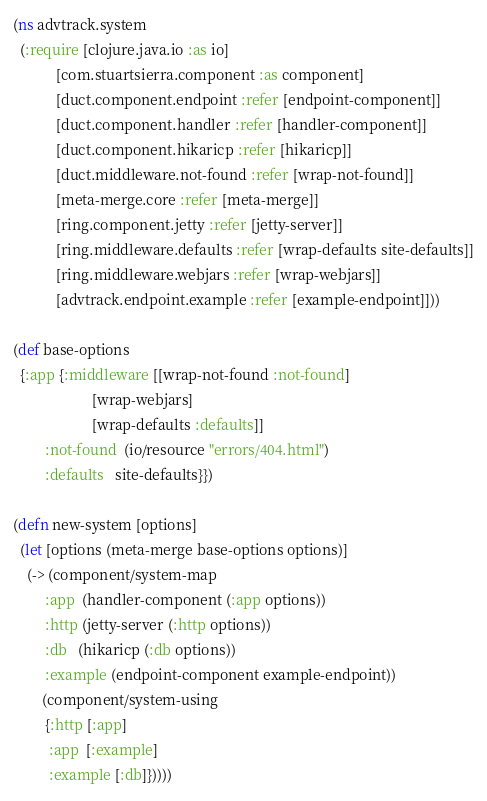<code> <loc_0><loc_0><loc_500><loc_500><_Clojure_>(ns advtrack.system
  (:require [clojure.java.io :as io]
            [com.stuartsierra.component :as component]
            [duct.component.endpoint :refer [endpoint-component]]
            [duct.component.handler :refer [handler-component]]
            [duct.component.hikaricp :refer [hikaricp]]
            [duct.middleware.not-found :refer [wrap-not-found]]
            [meta-merge.core :refer [meta-merge]]
            [ring.component.jetty :refer [jetty-server]]
            [ring.middleware.defaults :refer [wrap-defaults site-defaults]]
            [ring.middleware.webjars :refer [wrap-webjars]]
            [advtrack.endpoint.example :refer [example-endpoint]]))

(def base-options
  {:app {:middleware [[wrap-not-found :not-found]
                      [wrap-webjars]
                      [wrap-defaults :defaults]]
         :not-found  (io/resource "errors/404.html")
         :defaults   site-defaults}})

(defn new-system [options]
  (let [options (meta-merge base-options options)]
    (-> (component/system-map
         :app  (handler-component (:app options))
         :http (jetty-server (:http options))
         :db   (hikaricp (:db options))
         :example (endpoint-component example-endpoint))
        (component/system-using
         {:http [:app]
          :app  [:example]
          :example [:db]}))))
</code> 